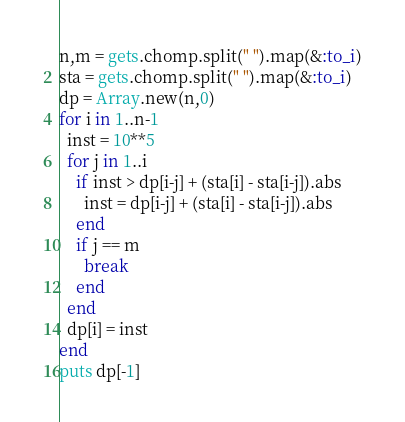Convert code to text. <code><loc_0><loc_0><loc_500><loc_500><_Ruby_>n,m = gets.chomp.split(" ").map(&:to_i)
sta = gets.chomp.split(" ").map(&:to_i)
dp = Array.new(n,0)
for i in 1..n-1
  inst = 10**5
  for j in 1..i
    if inst > dp[i-j] + (sta[i] - sta[i-j]).abs
      inst = dp[i-j] + (sta[i] - sta[i-j]).abs
    end
    if j == m
      break
    end
  end
  dp[i] = inst
end
puts dp[-1]
</code> 